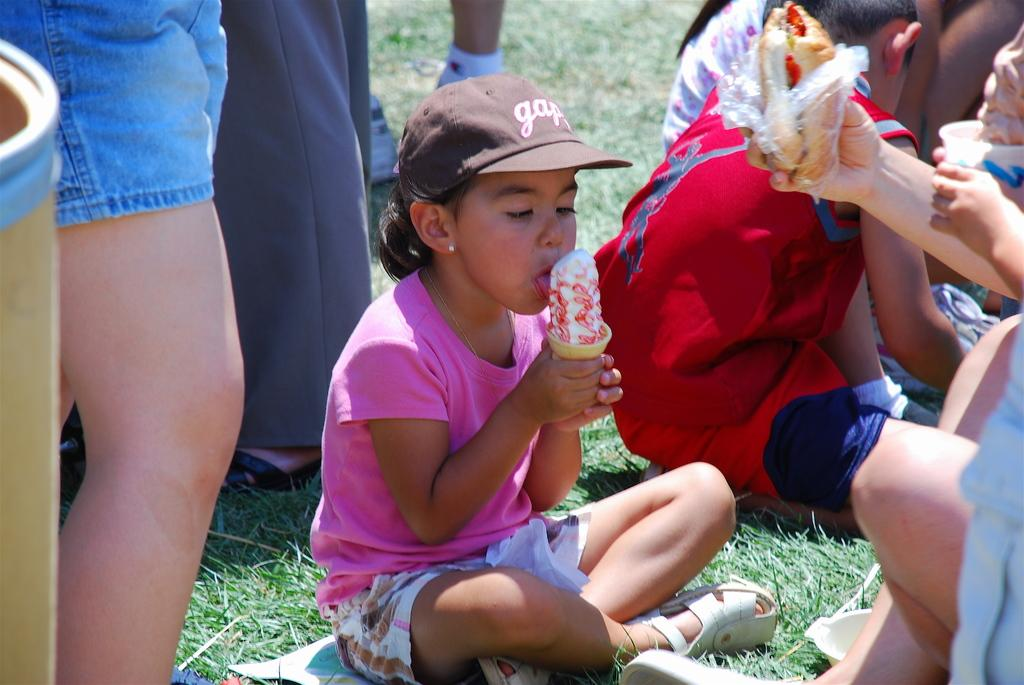<image>
Relay a brief, clear account of the picture shown. A girl wearing a baseball hat with the word "gap" on it 